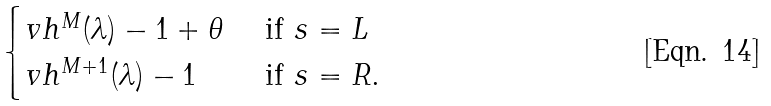<formula> <loc_0><loc_0><loc_500><loc_500>\begin{cases} v h ^ { M } ( \lambda ) - 1 + \theta & \text { if } s = L \\ v h ^ { M + 1 } ( \lambda ) - 1 & \text { if } s = R . \end{cases}</formula> 